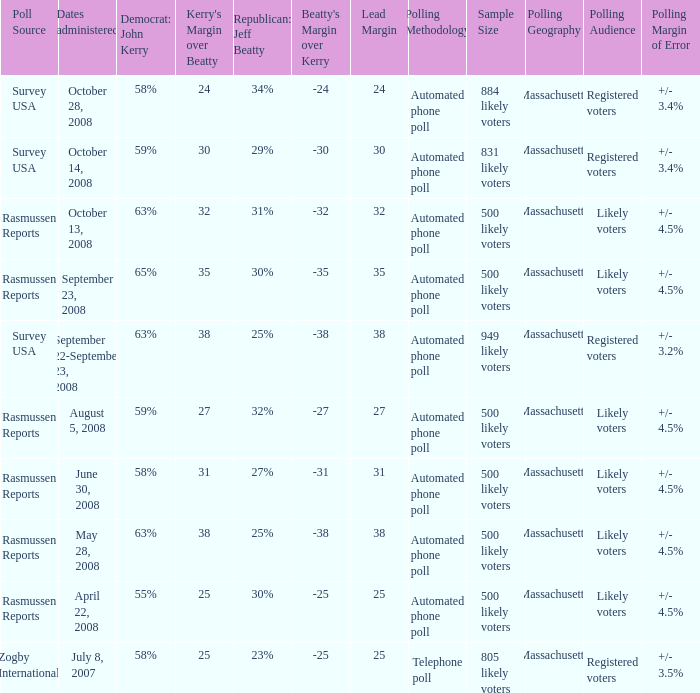Who is the poll source that has Republican: Jeff Beatty behind at 27%? Rasmussen Reports. 